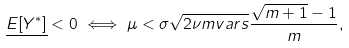<formula> <loc_0><loc_0><loc_500><loc_500>\underline { E [ Y ^ { * } ] } < 0 \iff \mu < \sigma \sqrt { 2 \nu m v a r s } \frac { \sqrt { m + 1 } - 1 } { m } ,</formula> 